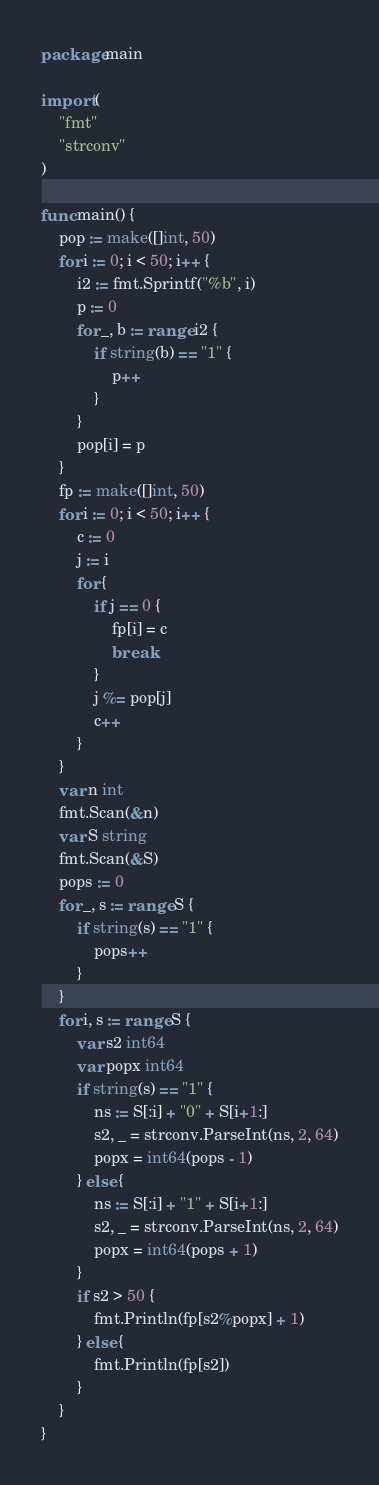Convert code to text. <code><loc_0><loc_0><loc_500><loc_500><_Go_>package main

import (
	"fmt"
	"strconv"
)

func main() {
	pop := make([]int, 50)
	for i := 0; i < 50; i++ {
		i2 := fmt.Sprintf("%b", i)
		p := 0
		for _, b := range i2 {
			if string(b) == "1" {
				p++
			}
		}
		pop[i] = p
	}
	fp := make([]int, 50)
	for i := 0; i < 50; i++ {
		c := 0
		j := i
		for {
			if j == 0 {
				fp[i] = c
				break
			}
			j %= pop[j]
			c++
		}
	}
	var n int
	fmt.Scan(&n)
	var S string
	fmt.Scan(&S)
	pops := 0
	for _, s := range S {
		if string(s) == "1" {
			pops++
		}
	}
	for i, s := range S {
		var s2 int64
		var popx int64
		if string(s) == "1" {
			ns := S[:i] + "0" + S[i+1:]
			s2, _ = strconv.ParseInt(ns, 2, 64)
			popx = int64(pops - 1)
		} else {
			ns := S[:i] + "1" + S[i+1:]
			s2, _ = strconv.ParseInt(ns, 2, 64)
			popx = int64(pops + 1)
		}
		if s2 > 50 {
			fmt.Println(fp[s2%popx] + 1)
		} else {
			fmt.Println(fp[s2])
		}
	}
}
</code> 